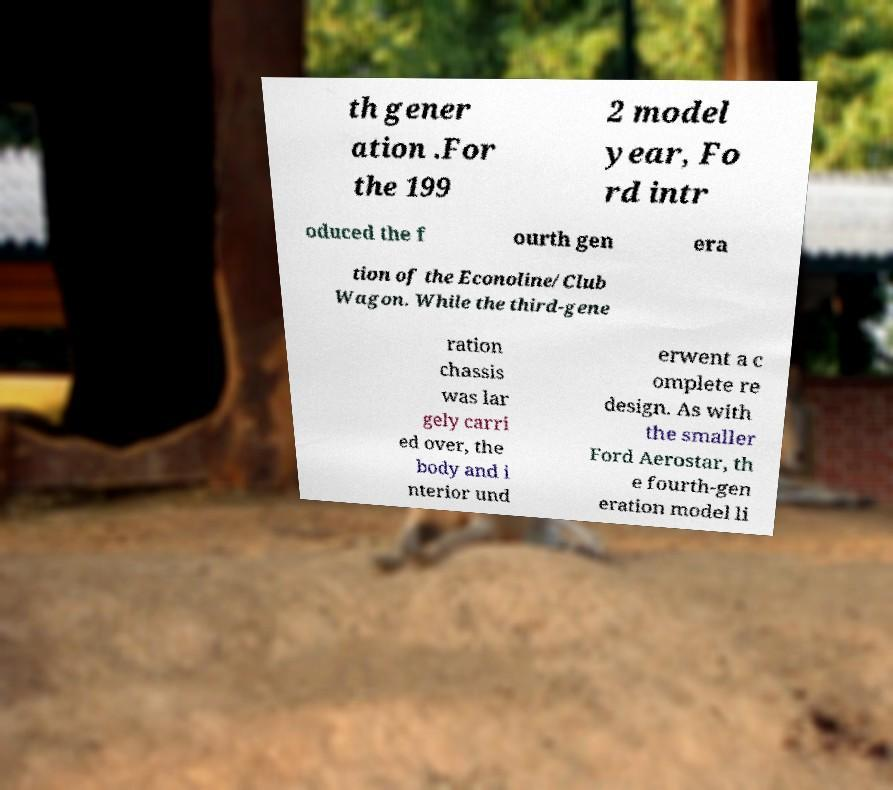Can you read and provide the text displayed in the image?This photo seems to have some interesting text. Can you extract and type it out for me? th gener ation .For the 199 2 model year, Fo rd intr oduced the f ourth gen era tion of the Econoline/Club Wagon. While the third-gene ration chassis was lar gely carri ed over, the body and i nterior und erwent a c omplete re design. As with the smaller Ford Aerostar, th e fourth-gen eration model li 